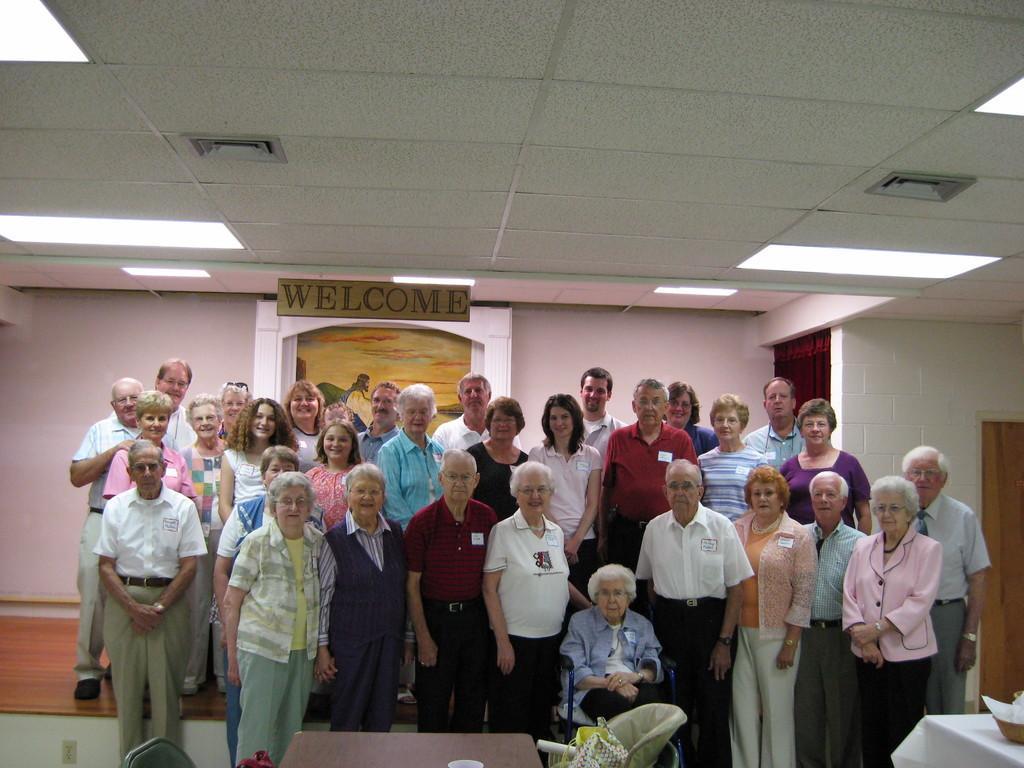Could you give a brief overview of what you see in this image? This is an inside view of a building and here we can see many people standing and posing and one of them is sitting on the chair. In the front, we can see some tables and chairs. In the background, there is a board, curtain and a wall. At the top, there are lights and there is a roof. 